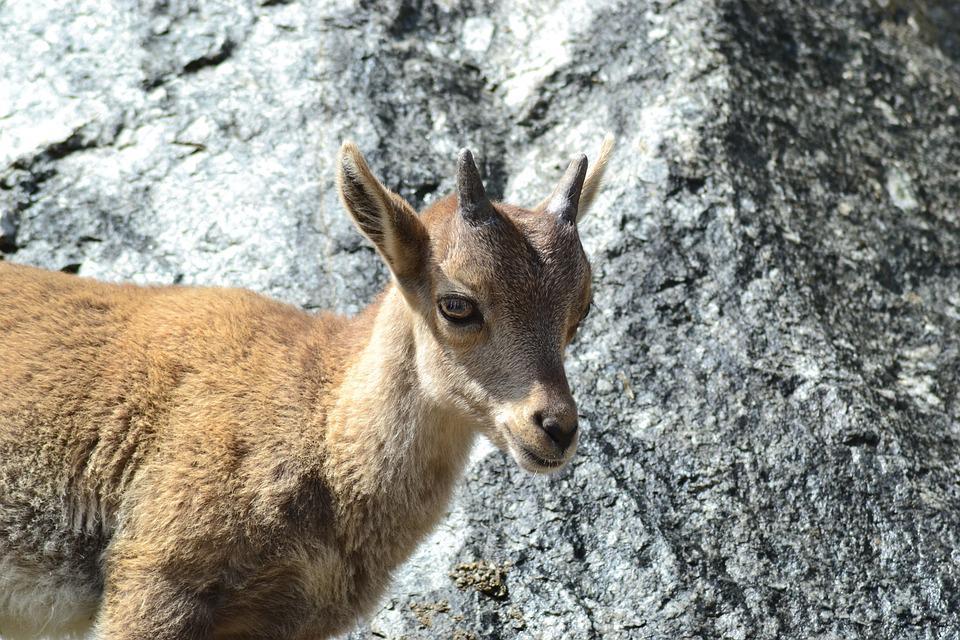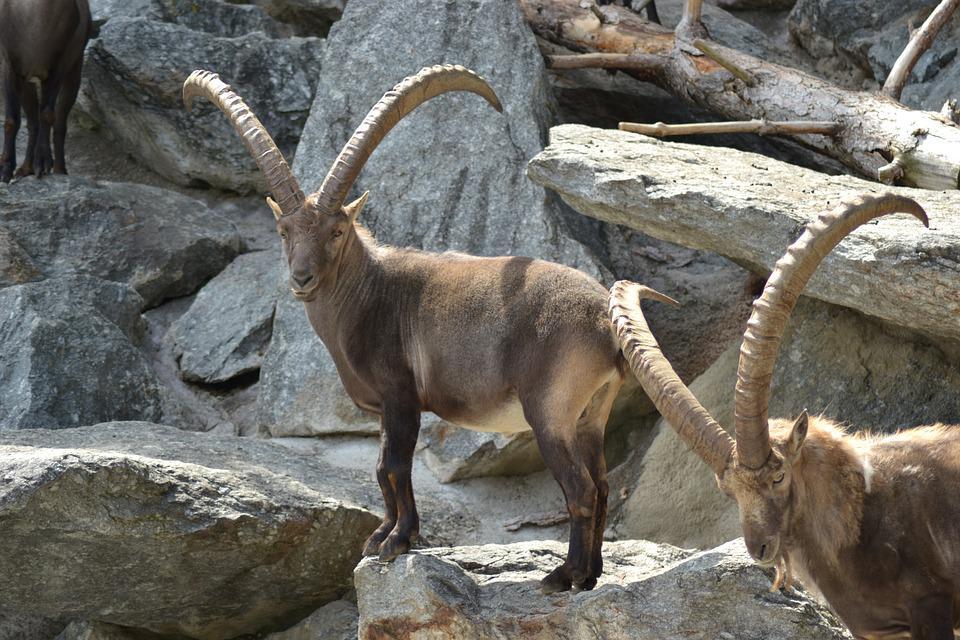The first image is the image on the left, the second image is the image on the right. For the images displayed, is the sentence "Some of the animals are butting heads." factually correct? Answer yes or no. No. 